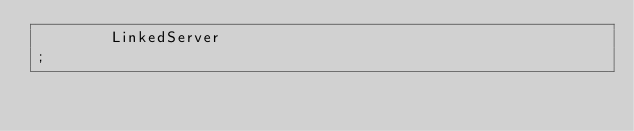<code> <loc_0><loc_0><loc_500><loc_500><_SQL_>        LinkedServer
;

</code> 